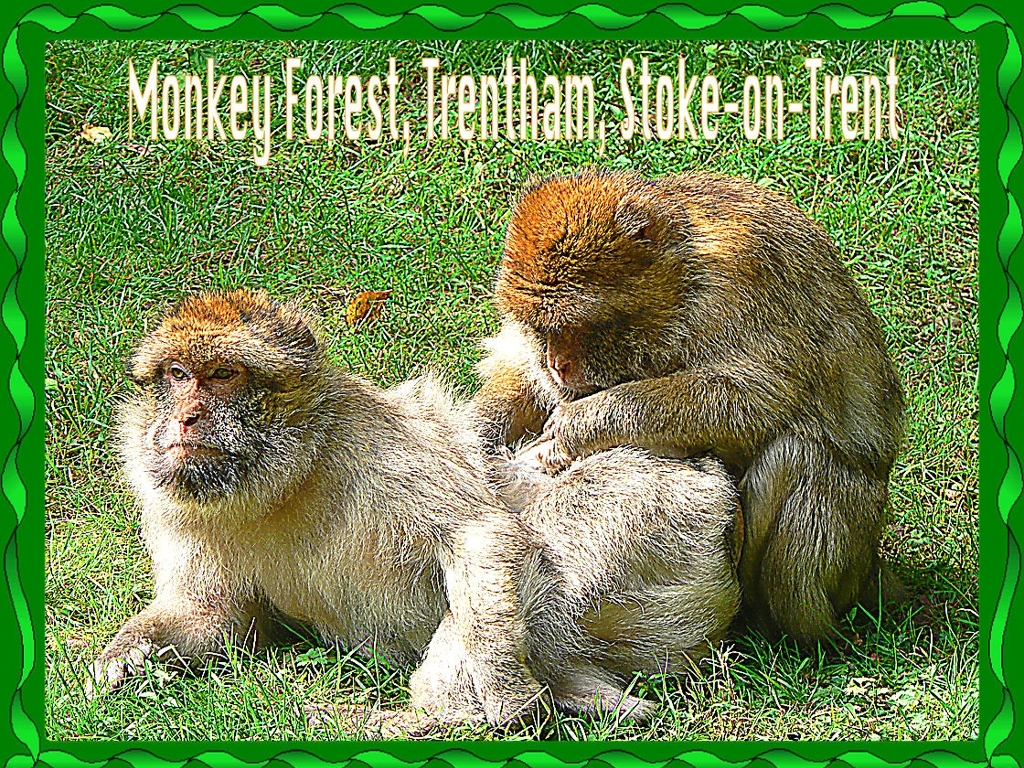What can you tell me about the behavior of the monkeys in this image? The monkeys are engaged in a social grooming activity, which is a common behavior among primates. It helps them to bond and maintain social structures, as well as to keep their fur clean and free from parasites. How does grooming affect their social dynamics? Grooming is a pivotal part of primate social life. It's not just about cleanliness; it's also about establishing and reinforcing social hierarchies and relationships. By grooming each other, monkeys show trust and affection, which can reduce conflict and promote cooperation within the group. 